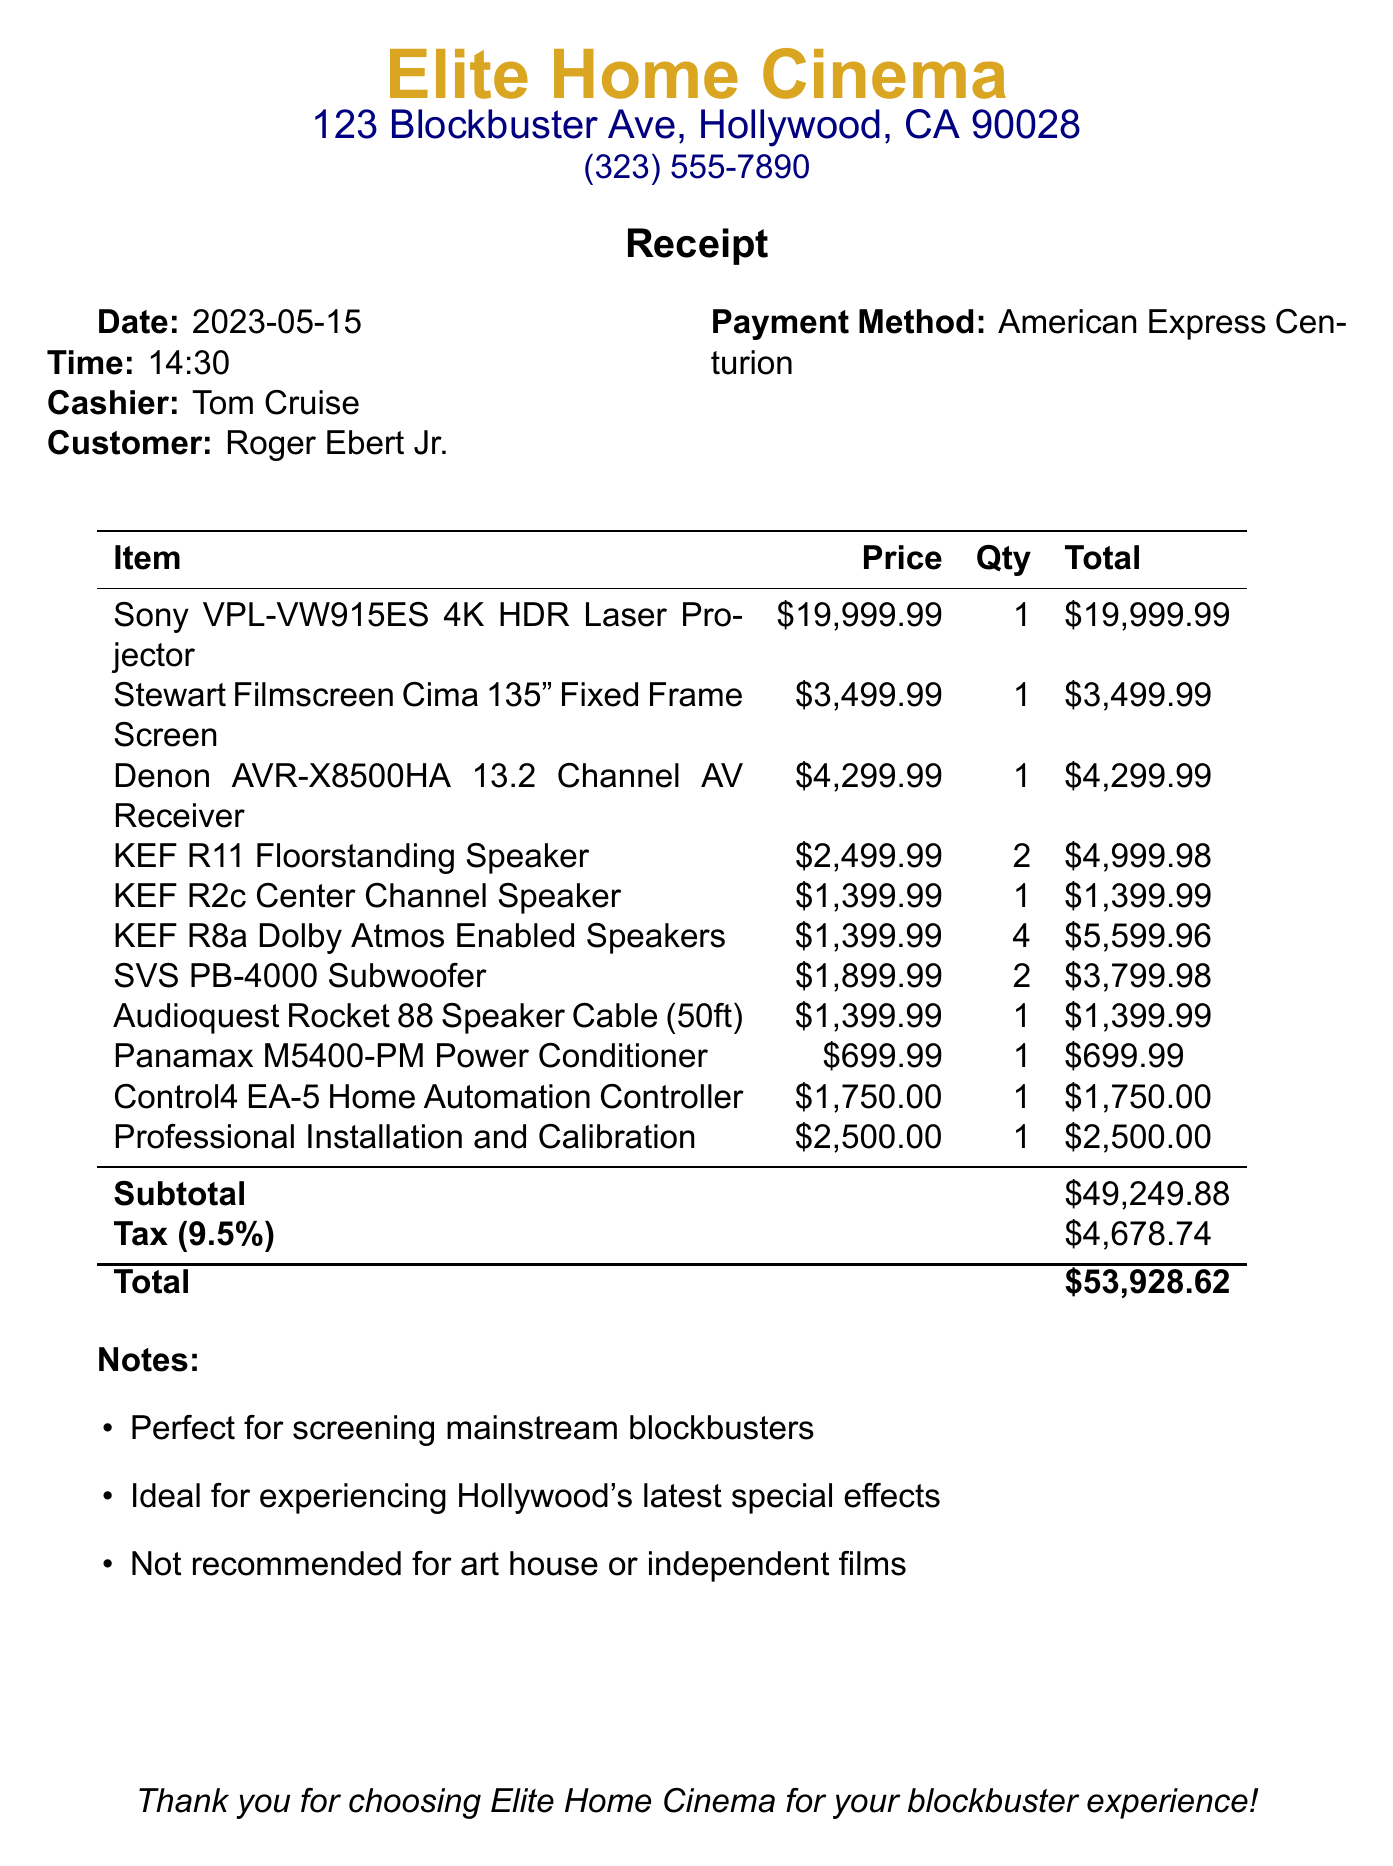what is the store name? The store name is clearly indicated at the top of the receipt.
Answer: Elite Home Cinema who was the cashier? The cashier's name is mentioned next to the cashier label.
Answer: Tom Cruise what was the date of purchase? The date is specified in a standard format on the receipt.
Answer: 2023-05-15 what is the total amount spent? The total amount is presented at the bottom of the receipt.
Answer: $53,928.62 how many KEF R8a Dolby Atmos Enabled Speakers were purchased? The quantity of each item is listed in the itemized table.
Answer: 4 what is the price of the Sony VPL-VW915ES 4K HDR Laser Projector? The price for this specific item is listed alongside its description.
Answer: $19,999.99 what payment method was used? The payment method is specified right next to the customer's details.
Answer: American Express Centurion what is the subtotal amount? The subtotal is clearly stated as part of the financial summary.
Answer: $49,249.88 what is included in the notes section? The notes detail the purpose and suitability of the equipment.
Answer: Perfect for screening mainstream blockbusters 